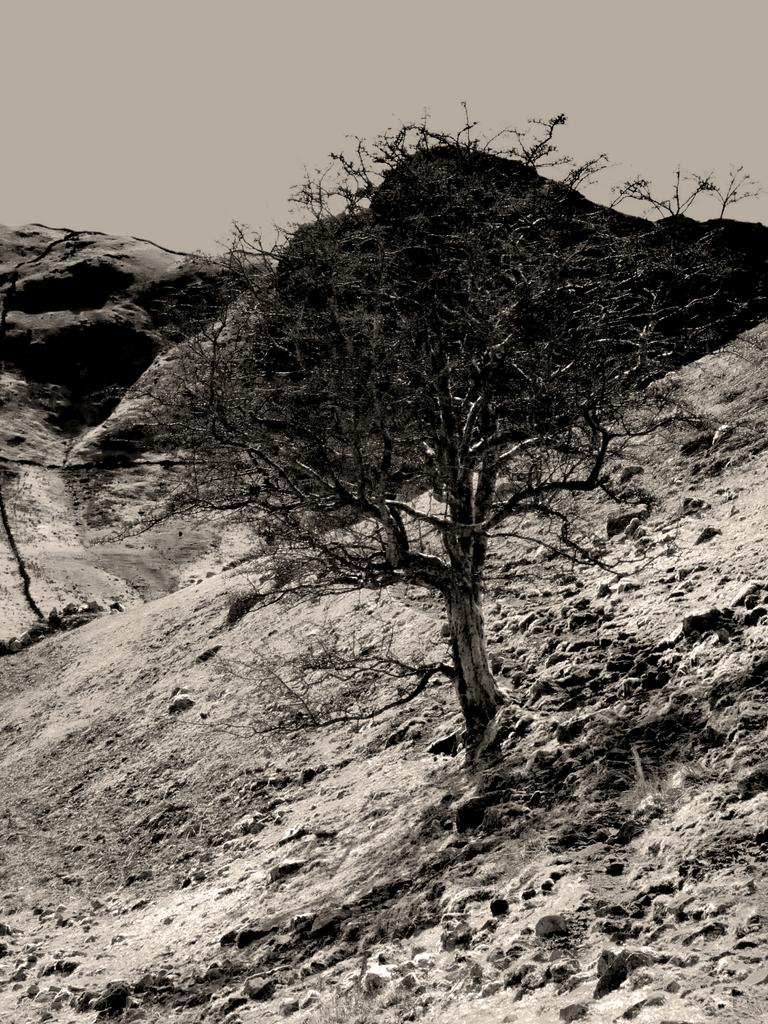What is the color scheme of the image? The image is black and white. What natural element can be seen in the image? There is a tree in the image. How would you describe the terrain where the tree is located? The land where the tree is located is sloppy. What type of geographical feature can be seen in the background? There are mountains visible behind the trees. What is the current stage of development for the tree in the image? The image does not provide information about the development stage of the tree. How much has the tree expanded since it was first planted? The image does not provide information about the tree's expansion since it was first planted. 